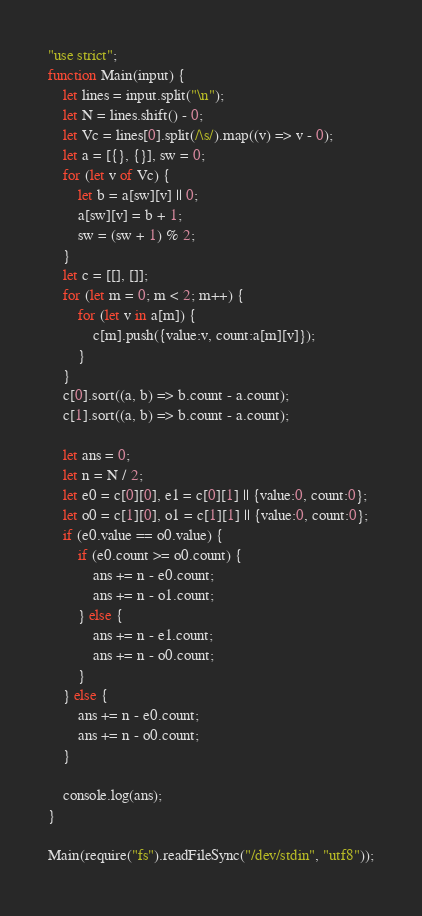<code> <loc_0><loc_0><loc_500><loc_500><_JavaScript_>"use strict";
function Main(input) {
    let lines = input.split("\n");
    let N = lines.shift() - 0;
    let Vc = lines[0].split(/\s/).map((v) => v - 0);
    let a = [{}, {}], sw = 0;
    for (let v of Vc) {
        let b = a[sw][v] || 0;
        a[sw][v] = b + 1;
        sw = (sw + 1) % 2;
    }
    let c = [[], []];
    for (let m = 0; m < 2; m++) {
        for (let v in a[m]) {
            c[m].push({value:v, count:a[m][v]});
        }
    }
    c[0].sort((a, b) => b.count - a.count);
    c[1].sort((a, b) => b.count - a.count);

    let ans = 0;
    let n = N / 2;
    let e0 = c[0][0], e1 = c[0][1] || {value:0, count:0};
    let o0 = c[1][0], o1 = c[1][1] || {value:0, count:0};
    if (e0.value == o0.value) {
        if (e0.count >= o0.count) {
            ans += n - e0.count;
            ans += n - o1.count;
        } else {
            ans += n - e1.count;
            ans += n - o0.count;
        }
    } else {
        ans += n - e0.count;
        ans += n - o0.count;
    }

    console.log(ans);
}

Main(require("fs").readFileSync("/dev/stdin", "utf8"));
</code> 